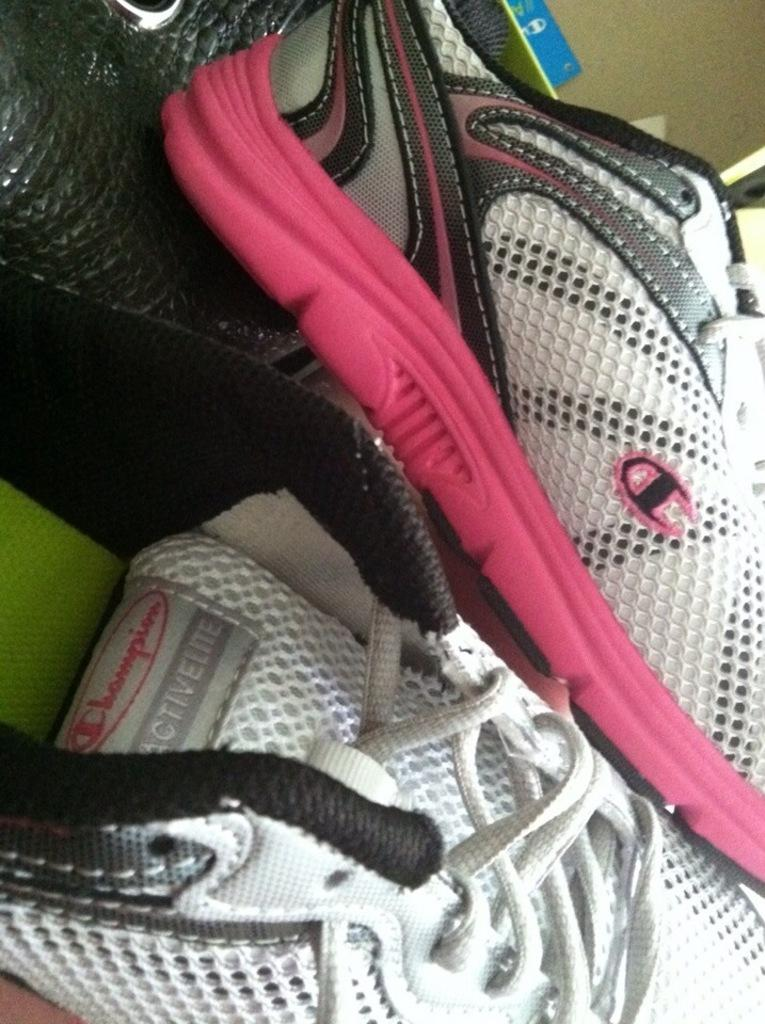What objects are in the foreground of the image? There are shoes in the foreground of the image. Where is the faucet located in the image? There is no faucet present in the image; it only features shoes in the foreground. 